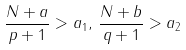Convert formula to latex. <formula><loc_0><loc_0><loc_500><loc_500>\frac { N + a } { p + 1 } > a _ { 1 } , \, \frac { N + b } { q + 1 } > a _ { 2 }</formula> 